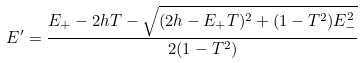Convert formula to latex. <formula><loc_0><loc_0><loc_500><loc_500>E ^ { \prime } = \frac { E _ { + } - 2 h T - \sqrt { ( 2 h - E _ { + } T ) ^ { 2 } + ( 1 - T ^ { 2 } ) E _ { - } ^ { 2 } } } { 2 ( 1 - T ^ { 2 } ) }</formula> 